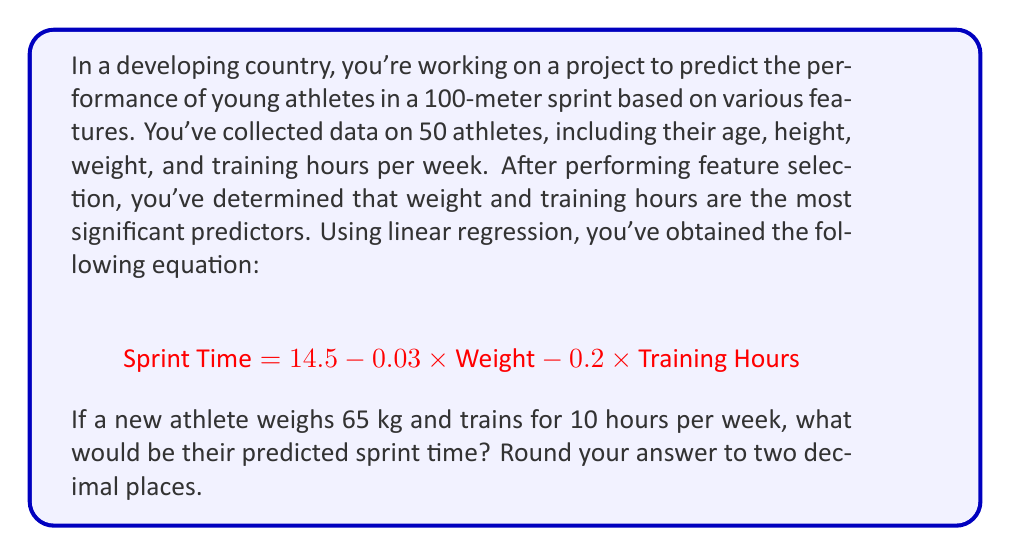Provide a solution to this math problem. To solve this problem, we'll follow these steps:

1. Identify the given information:
   - Regression equation: $$\text{Sprint Time} = 14.5 - 0.03 \times \text{Weight} - 0.2 \times \text{Training Hours}$$
   - New athlete's weight: 65 kg
   - New athlete's training hours: 10 hours/week

2. Substitute the values into the equation:
   $$\text{Sprint Time} = 14.5 - 0.03 \times 65 - 0.2 \times 10$$

3. Calculate the weight component:
   $$-0.03 \times 65 = -1.95$$

4. Calculate the training hours component:
   $$-0.2 \times 10 = -2$$

5. Sum up all components:
   $$14.5 + (-1.95) + (-2) = 10.55$$

6. Round the result to two decimal places:
   $$10.55 \approx 10.55$$

This prediction can be used to set realistic goals for the athlete and tailor their training program accordingly, which aligns with the education specialist's aim of incorporating sports into the curriculum to enhance learning outcomes.
Answer: 10.55 seconds 